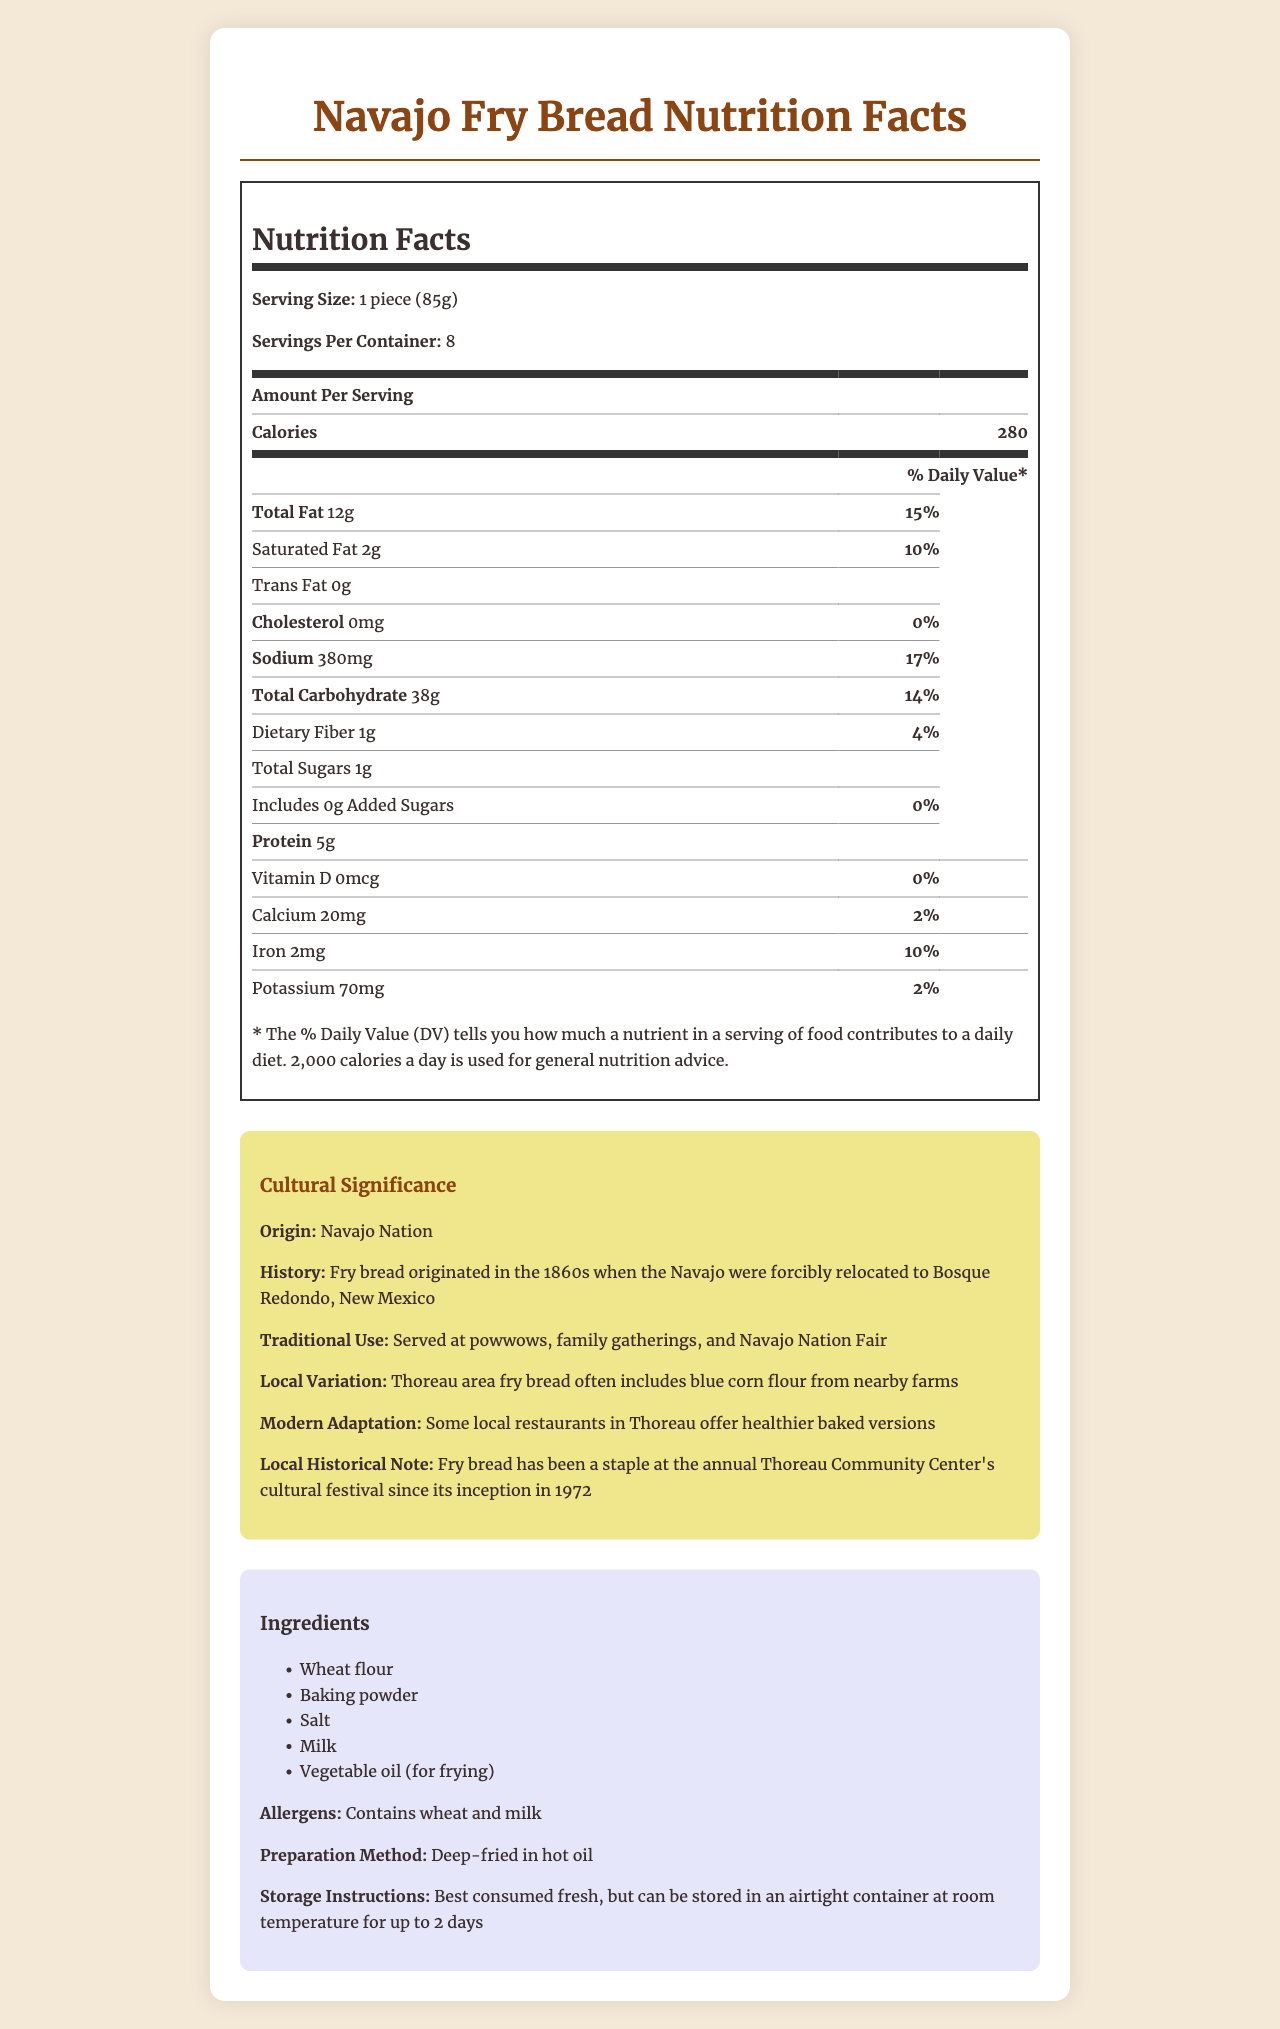What is the serving size for Navajo fry bread? The serving size is listed at the top of the Nutrition Facts section as "1 piece (85g)".
Answer: 1 piece (85g) How many calories are there per serving? The number of calories per serving is listed prominently in the Nutrition Facts section as 280 calories.
Answer: 280 What is the total fat content in a serving? The Nutrition Facts section shows that the Total Fat content is 12 grams per serving.
Answer: 12 grams How much sodium is in one serving? The Nutrition Facts detail the sodium content as 380 milligrams per serving.
Answer: 380 milligrams Does the Navajo fry bread contain any added sugars? The Nutrition Facts section lists Added Sugars as 0 grams, indicating there are no added sugars.
Answer: No Which historical event led to the creation of Navajo fry bread? A. The California Gold Rush B. The forced relocation to Bosque Redondo C. The construction of the transcontinental railroad The Cultural Significance section states that fry bread originated when the Navajo were forcibly relocated to Bosque Redondo in the 1860s.
Answer: B What is the primary traditional use of Navajo fry bread? A. As a breakfast food B. Served at powwows, family gatherings, and Navajo Nation Fair C. As a dessert According to the Cultural Significance section, fry bread is traditionally served at powwows, family gatherings, and the Navajo Nation Fair.
Answer: B Is there any cholesterol in a serving of Navajo fry bread? The Nutrition Facts clearly state that the cholesterol content per serving is 0 milligrams.
Answer: No Summarize the cultural significance of Navajo fry bread. The Cultural Significance section provides detailed information about the origin, traditional use, local variations, modern adaptations, and a historical note regarding Navajo fry bread.
Answer: Navajo fry bread originates from the Navajo Nation and was created during the 1860s. It holds significant cultural value, being traditionally served at powwows, family gatherings, and the Navajo Nation Fair. Local variations include the use of blue corn flour, and modern adaptations feature healthier baked versions. It has also been a staple at Thoreau Community Center's cultural festival since 1972. Which ingredient in the Navajo fry bread might be a concern for someone with a gluten allergy? The Ingredients section lists wheat flour as one of the components, which could be a concern for someone with a gluten allergy.
Answer: Wheat flour What is the total carbohydrate content in a serving of Navajo fry bread? The Nutrition Facts section notes that the Total Carbohydrate content per serving is 38 grams.
Answer: 38 grams Which nutrient has the highest % Daily Value in one serving of fry bread? The Nutrition Facts section shows that Sodium has the highest % Daily Value at 17%.
Answer: Sodium (17%) Can this nutrition label inform you about the Vitamin C content in fry bread? The document does not contain any details about the Vitamin C content in Navajo fry bread.
Answer: Not enough information What is the recommended storage instruction for fry bread? The Ingredients section under storage instructions outlines these recommendations.
Answer: Best consumed fresh, but can be stored in an airtight container at room temperature for up to 2 days How much protein does one serving of Navajo fry bread contain? The Nutrition Facts section lists the protein content as 5 grams per serving.
Answer: 5 grams What type of flour is sometimes used in local variations of Thoreau area fry bread? The Cultural Significance section notes that Thoreau area fry bread often includes blue corn flour from nearby farms.
Answer: Blue corn flour 